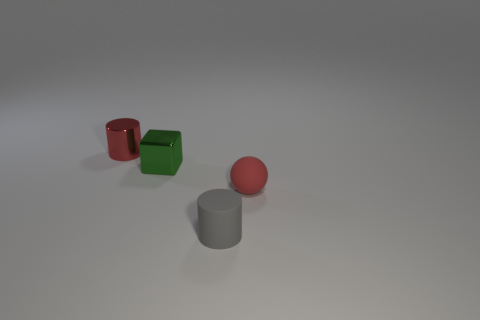Add 2 small red matte things. How many objects exist? 6 Subtract all cubes. How many objects are left? 3 Add 3 brown matte spheres. How many brown matte spheres exist? 3 Subtract 1 red balls. How many objects are left? 3 Subtract all green metallic cubes. Subtract all small brown metallic spheres. How many objects are left? 3 Add 3 red metal cylinders. How many red metal cylinders are left? 4 